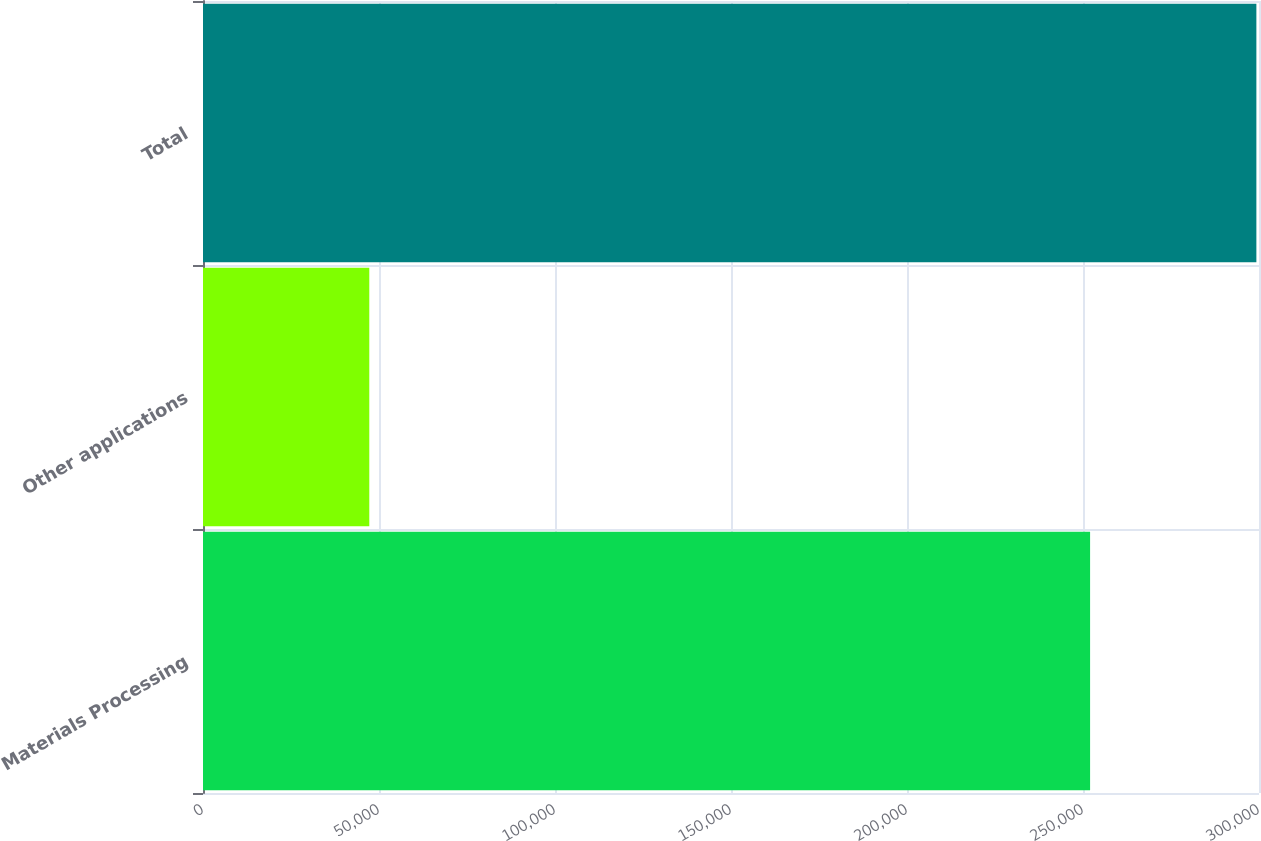<chart> <loc_0><loc_0><loc_500><loc_500><bar_chart><fcel>Materials Processing<fcel>Other applications<fcel>Total<nl><fcel>252014<fcel>47242<fcel>299256<nl></chart> 